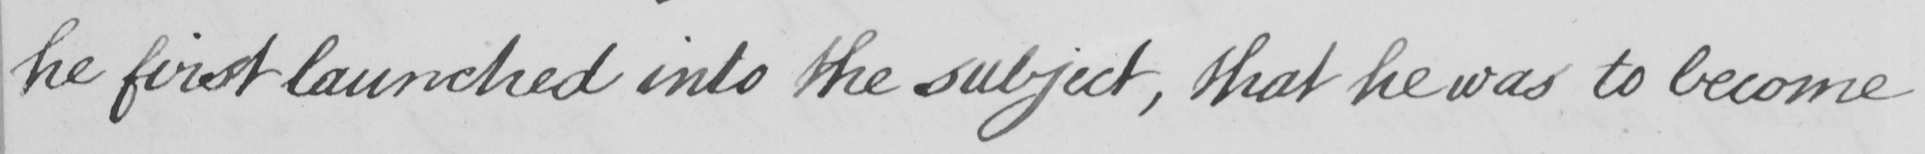Please provide the text content of this handwritten line. he first launched into the subject , that he was to become 